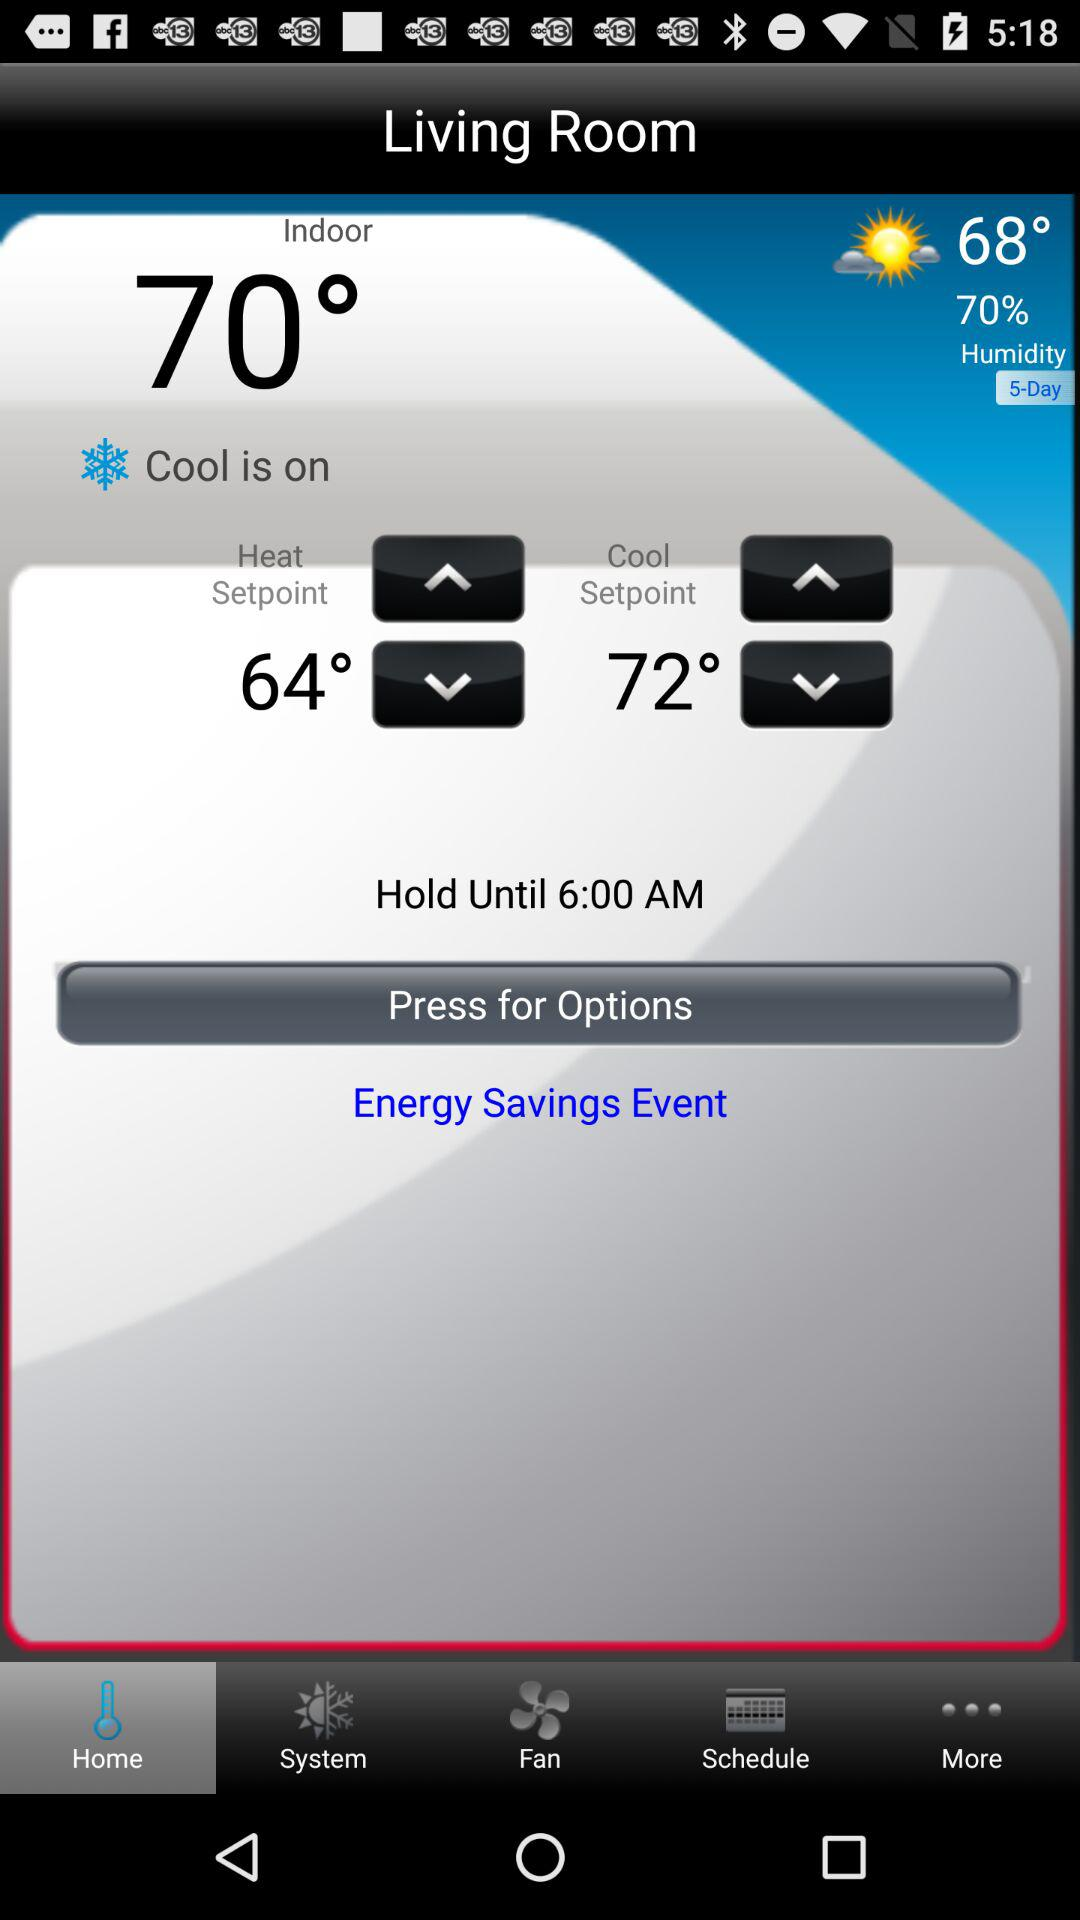What is the difference between the indoor and outdoor temperatures?
Answer the question using a single word or phrase. 2° 